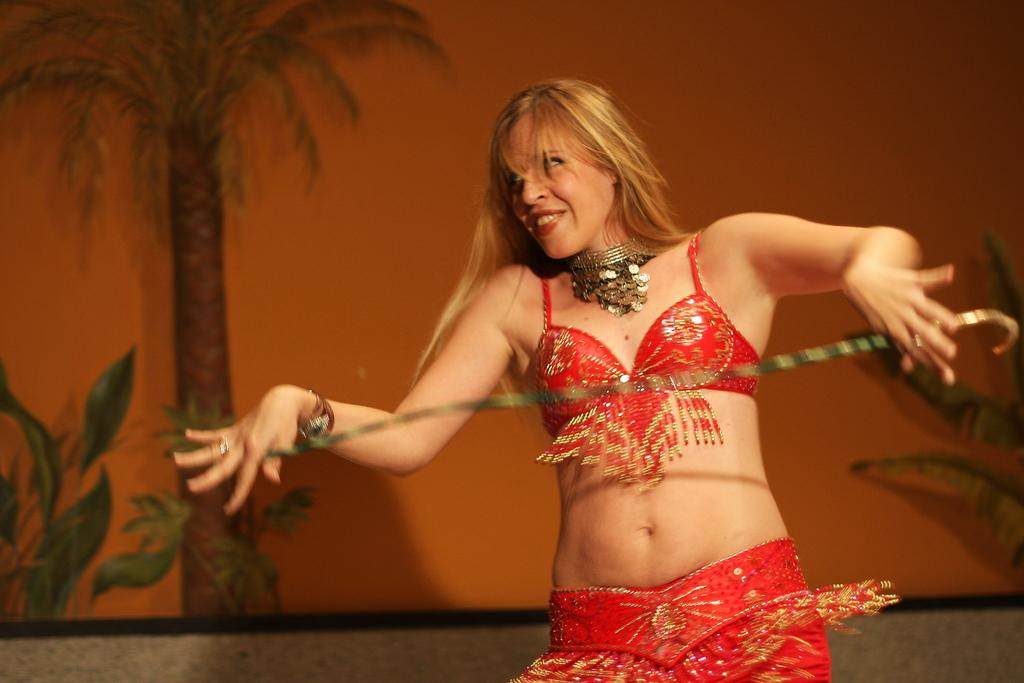What is the main subject of the image? There is a person in the image. What is the person doing in the image? The person is holding an object. What color is the background of the image? The background of the image is orange in color. Can you identify any natural elements in the image? Yes, there is a tree depicted in the image. What type of leather is being used to reduce friction on the plane in the image? There is no plane or leather present in the image, and therefore no such activity can be observed. 